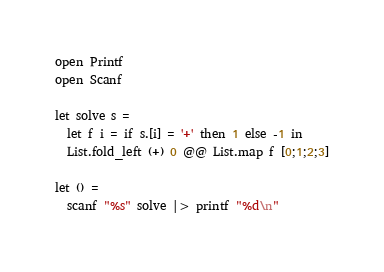Convert code to text. <code><loc_0><loc_0><loc_500><loc_500><_OCaml_>open Printf
open Scanf

let solve s =
  let f i = if s.[i] = '+' then 1 else -1 in
  List.fold_left (+) 0 @@ List.map f [0;1;2;3]

let () =
  scanf "%s" solve |> printf "%d\n"
</code> 